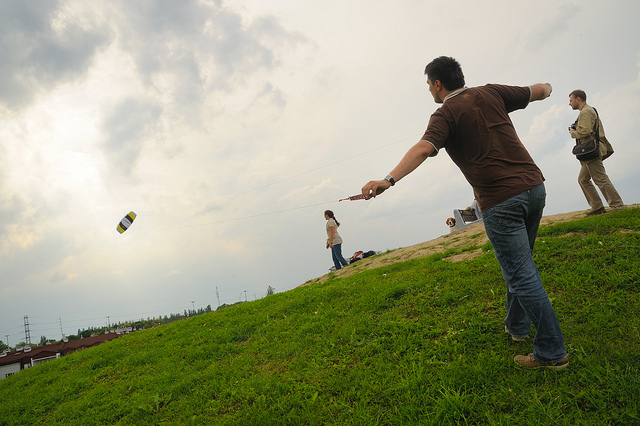Can you infer the relationship between the people in the image? While the specific relationships cannot be determined with certainty without more context, their presence together in the open field and engagement in a common activity suggests they could be friends or family members enjoying a recreational pastime together. 